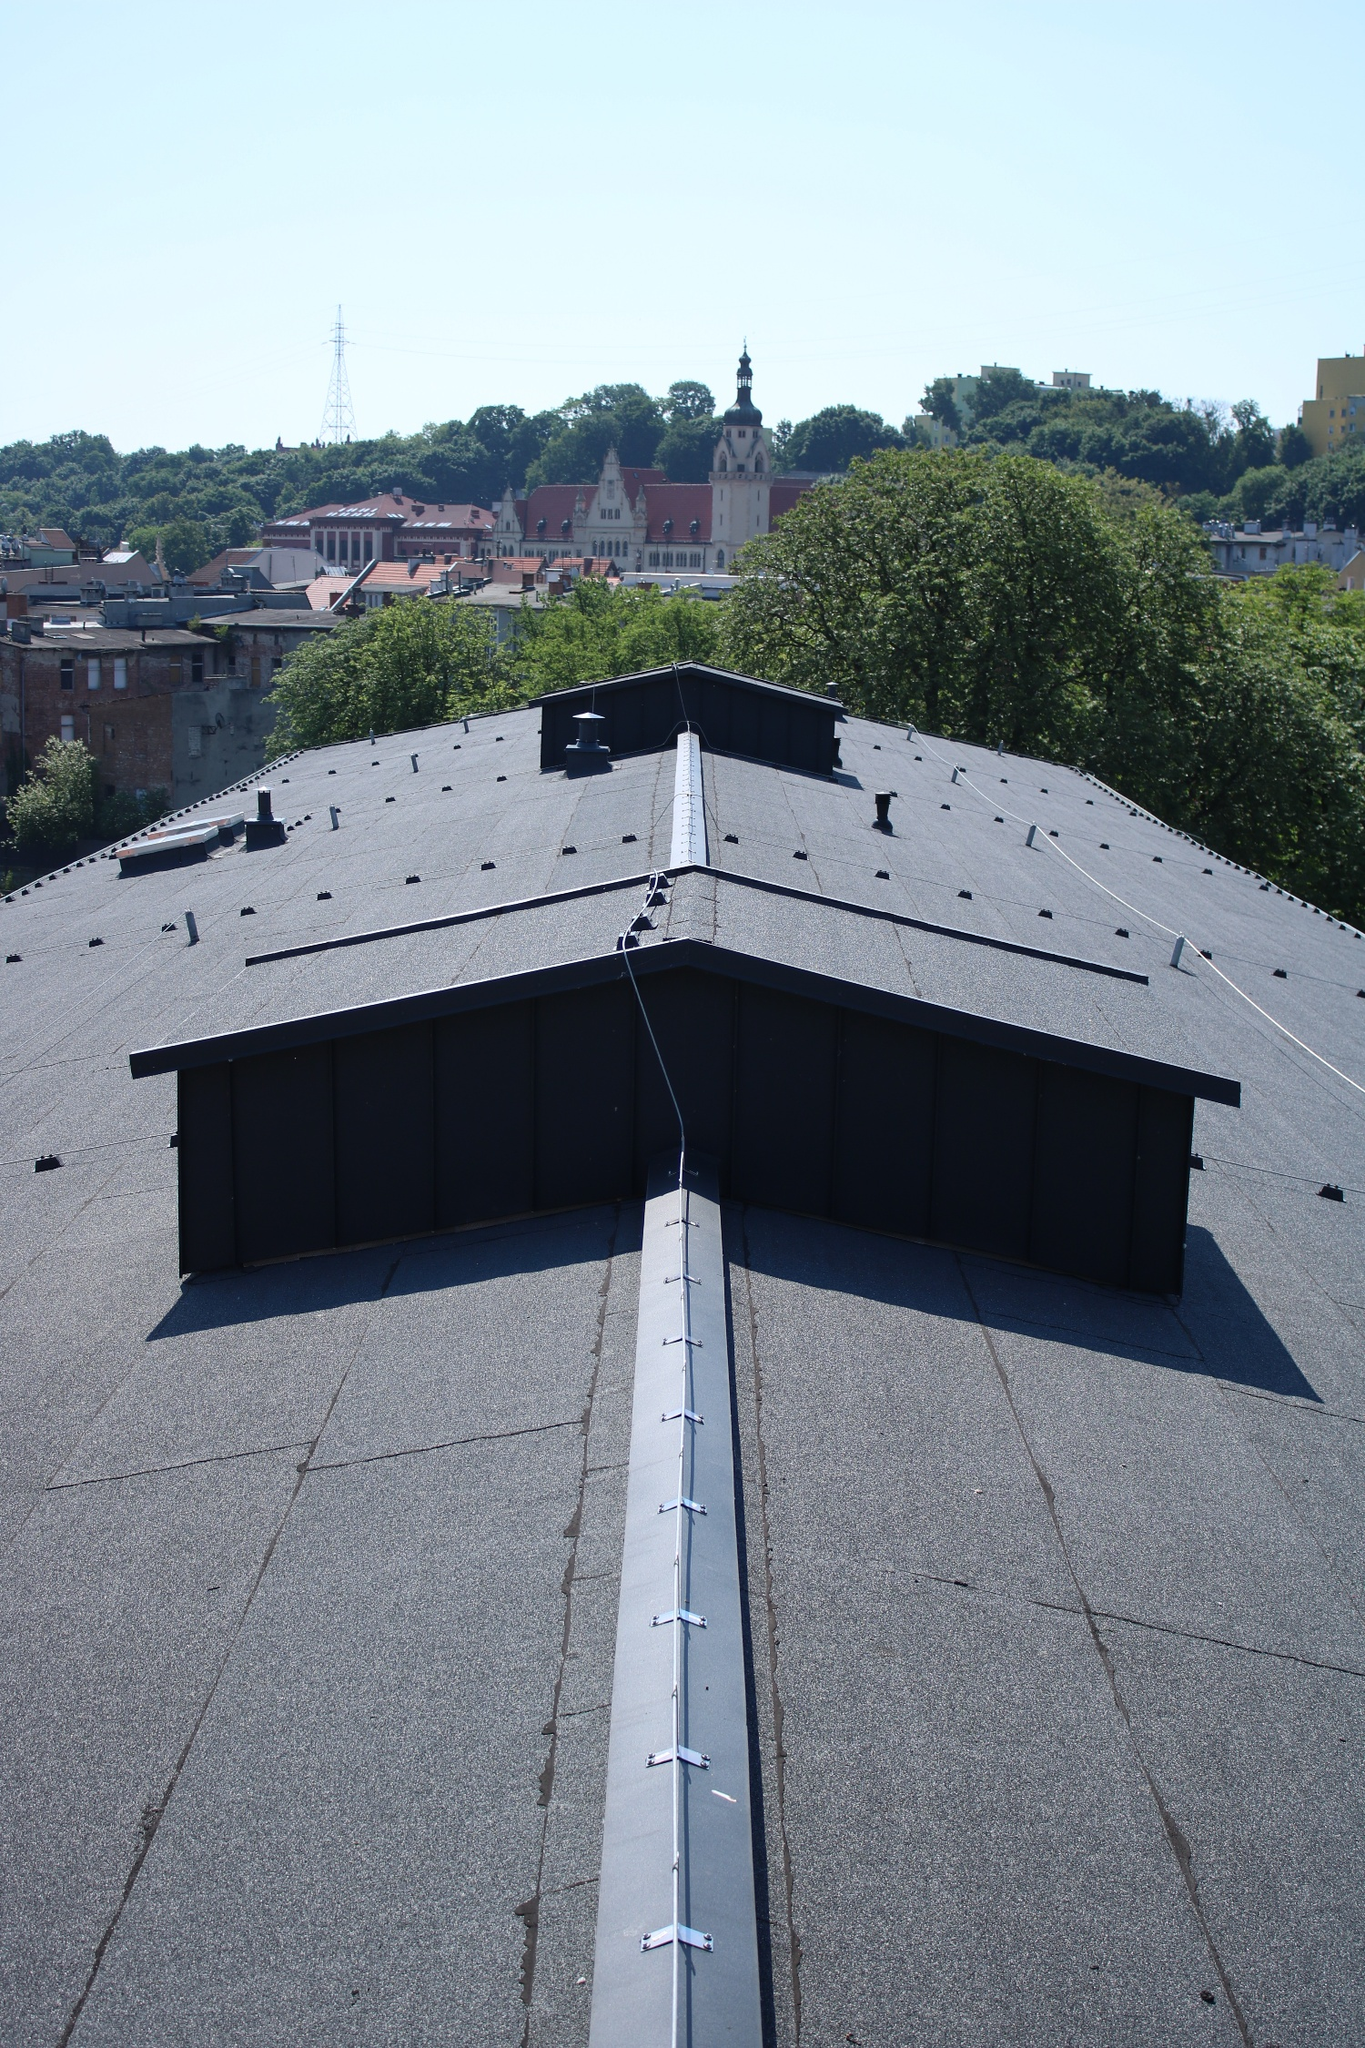Can you imagine a story set in this cityscape? In the bustling city beneath the clear, blue sky, a story of intrigue and discovery unfolds. Amidst the shadows of towering spires and modern rooftops, a young historian, Elena, stumbles upon an ancient manuscript hidden within the depths of the grand church. The document alludes to a forgotten treasure hidden somewhere in the city, a relic from the medieval era meant to safeguard the city's prosperity. As Elena deciphers the manuscript, she unravels clues that lead her through the maze of rooftops and alleyways, each step drawing her closer to the heart of the mystery. Her journey is fraught with challenges as she battles elements, deciphers codes, and faces an enigmatic organization determined to keep the secret hidden. Amidst the contrast of old and new buildings, Elena delves into the city's rich history, unlocking secrets that could reshape its future. The birds-eye view of the cityscape serves as a constant reminder of the sprawling complexity and hidden stories within its bounds, mirroring Elena's quest to unveil the treasure that has eluded generations. 